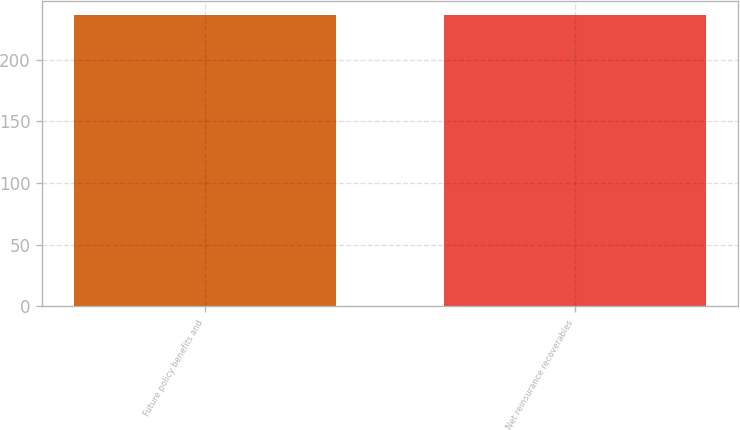Convert chart to OTSL. <chart><loc_0><loc_0><loc_500><loc_500><bar_chart><fcel>Future policy benefits and<fcel>Net reinsurance recoverables<nl><fcel>236<fcel>236.1<nl></chart> 